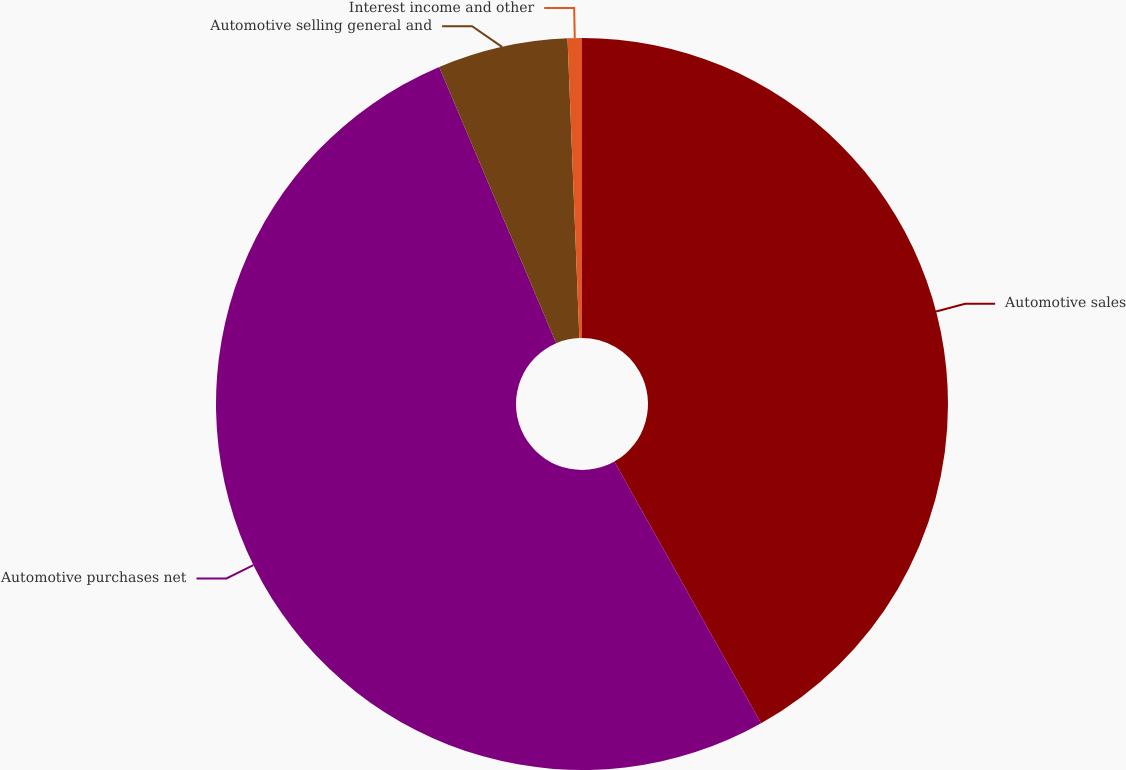<chart> <loc_0><loc_0><loc_500><loc_500><pie_chart><fcel>Automotive sales<fcel>Automotive purchases net<fcel>Automotive selling general and<fcel>Interest income and other<nl><fcel>41.86%<fcel>51.76%<fcel>5.75%<fcel>0.63%<nl></chart> 